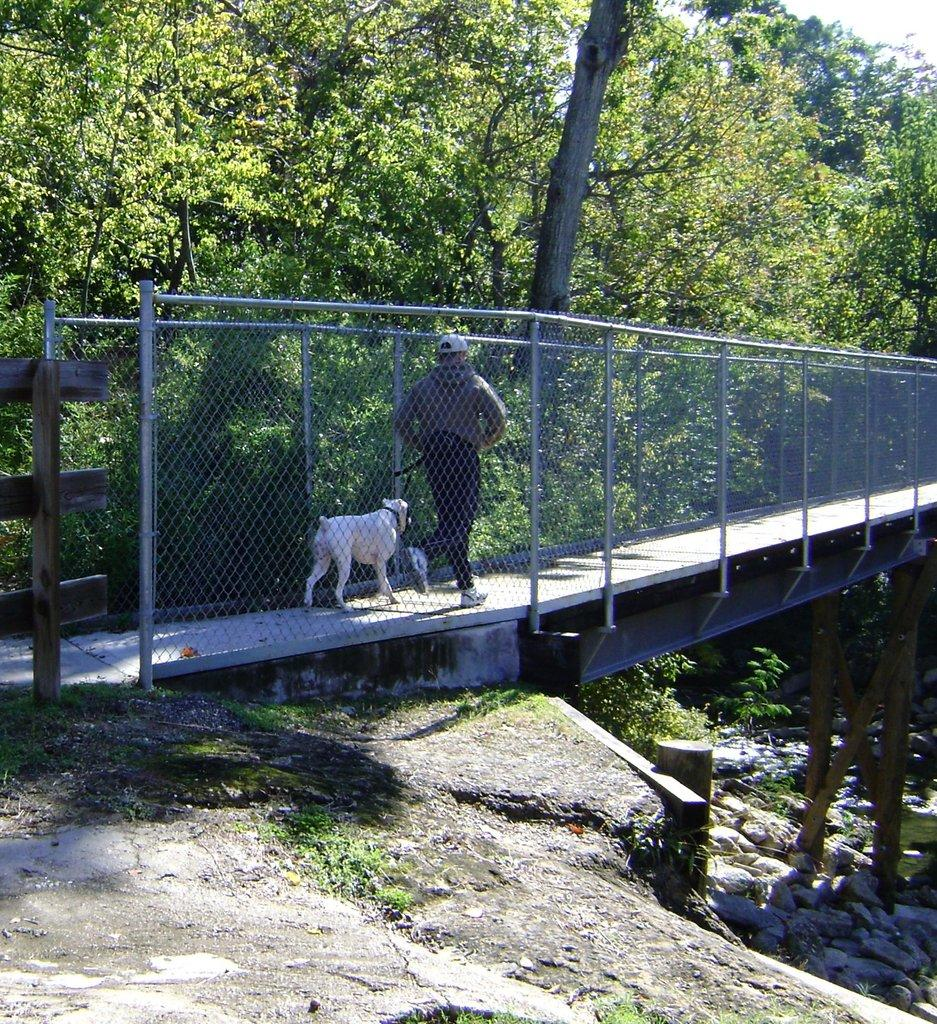What is the person in the image doing? The person is walking in the image. Is the person alone in the image? No, the person is accompanied by a dog. Where are they walking? They are on a bridge. What can be seen on the left side of the image? There are trees on the left side of the image. What is on the right side of the image? There are stones on the right side of the image. What word is written on the trees in the image? There is no word written on the trees in the image; they are just trees. How many weeks have passed since the person and dog started walking in the image? The image is a still photograph, so it does not depict the passage of time in terms of weeks. 